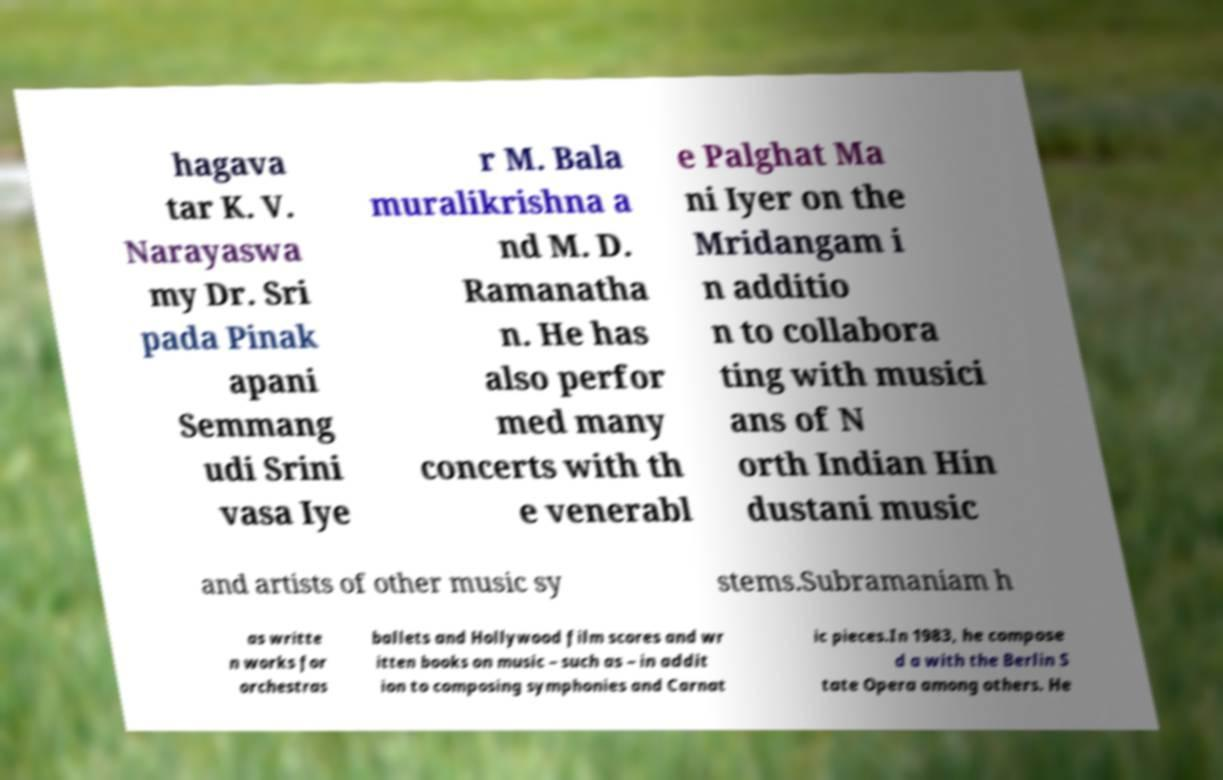There's text embedded in this image that I need extracted. Can you transcribe it verbatim? hagava tar K. V. Narayaswa my Dr. Sri pada Pinak apani Semmang udi Srini vasa Iye r M. Bala muralikrishna a nd M. D. Ramanatha n. He has also perfor med many concerts with th e venerabl e Palghat Ma ni Iyer on the Mridangam i n additio n to collabora ting with musici ans of N orth Indian Hin dustani music and artists of other music sy stems.Subramaniam h as writte n works for orchestras ballets and Hollywood film scores and wr itten books on music – such as – in addit ion to composing symphonies and Carnat ic pieces.In 1983, he compose d a with the Berlin S tate Opera among others. He 